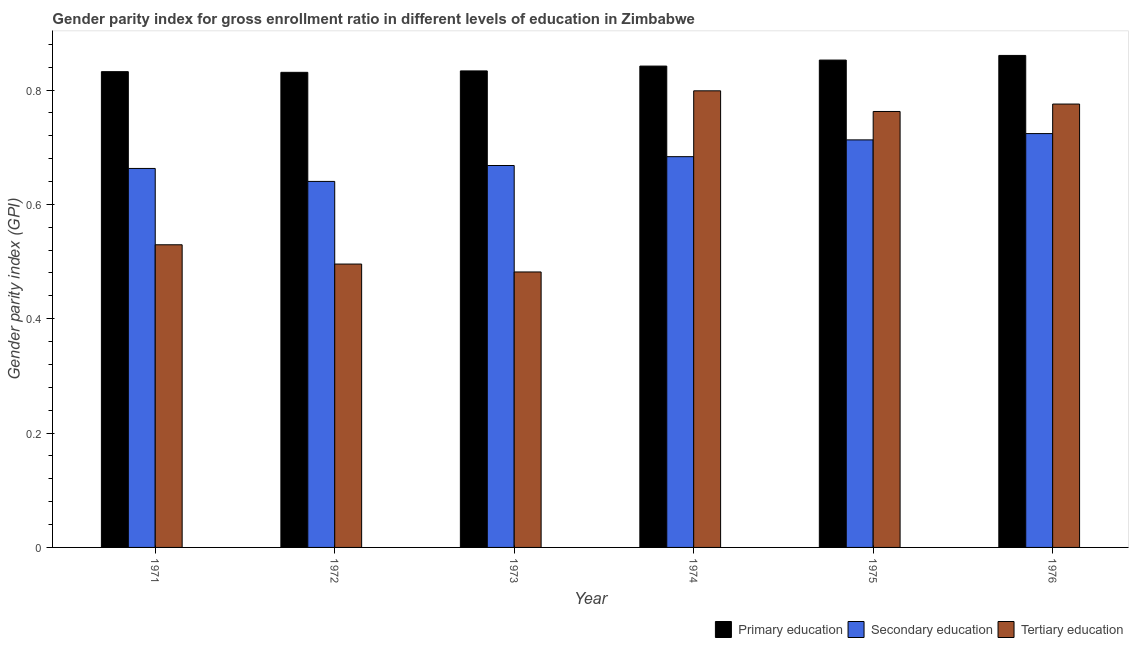How many different coloured bars are there?
Make the answer very short. 3. How many groups of bars are there?
Offer a terse response. 6. How many bars are there on the 6th tick from the right?
Ensure brevity in your answer.  3. What is the label of the 1st group of bars from the left?
Offer a very short reply. 1971. In how many cases, is the number of bars for a given year not equal to the number of legend labels?
Give a very brief answer. 0. What is the gender parity index in primary education in 1972?
Give a very brief answer. 0.83. Across all years, what is the maximum gender parity index in tertiary education?
Make the answer very short. 0.8. Across all years, what is the minimum gender parity index in primary education?
Offer a terse response. 0.83. In which year was the gender parity index in tertiary education maximum?
Offer a very short reply. 1974. In which year was the gender parity index in secondary education minimum?
Offer a terse response. 1972. What is the total gender parity index in tertiary education in the graph?
Ensure brevity in your answer.  3.84. What is the difference between the gender parity index in primary education in 1972 and that in 1974?
Your answer should be compact. -0.01. What is the difference between the gender parity index in secondary education in 1973 and the gender parity index in tertiary education in 1976?
Give a very brief answer. -0.06. What is the average gender parity index in primary education per year?
Keep it short and to the point. 0.84. In the year 1975, what is the difference between the gender parity index in secondary education and gender parity index in primary education?
Your answer should be compact. 0. What is the ratio of the gender parity index in tertiary education in 1972 to that in 1976?
Your response must be concise. 0.64. What is the difference between the highest and the second highest gender parity index in tertiary education?
Your response must be concise. 0.02. What is the difference between the highest and the lowest gender parity index in secondary education?
Make the answer very short. 0.08. Is the sum of the gender parity index in secondary education in 1971 and 1975 greater than the maximum gender parity index in tertiary education across all years?
Your response must be concise. Yes. What does the 2nd bar from the left in 1971 represents?
Ensure brevity in your answer.  Secondary education. How many bars are there?
Your answer should be very brief. 18. Are all the bars in the graph horizontal?
Keep it short and to the point. No. Are the values on the major ticks of Y-axis written in scientific E-notation?
Your answer should be compact. No. How many legend labels are there?
Offer a very short reply. 3. How are the legend labels stacked?
Your response must be concise. Horizontal. What is the title of the graph?
Your answer should be compact. Gender parity index for gross enrollment ratio in different levels of education in Zimbabwe. What is the label or title of the Y-axis?
Your response must be concise. Gender parity index (GPI). What is the Gender parity index (GPI) of Primary education in 1971?
Provide a succinct answer. 0.83. What is the Gender parity index (GPI) in Secondary education in 1971?
Give a very brief answer. 0.66. What is the Gender parity index (GPI) in Tertiary education in 1971?
Keep it short and to the point. 0.53. What is the Gender parity index (GPI) of Primary education in 1972?
Give a very brief answer. 0.83. What is the Gender parity index (GPI) of Secondary education in 1972?
Ensure brevity in your answer.  0.64. What is the Gender parity index (GPI) of Tertiary education in 1972?
Keep it short and to the point. 0.5. What is the Gender parity index (GPI) of Primary education in 1973?
Your answer should be compact. 0.83. What is the Gender parity index (GPI) of Secondary education in 1973?
Your answer should be compact. 0.67. What is the Gender parity index (GPI) in Tertiary education in 1973?
Your answer should be very brief. 0.48. What is the Gender parity index (GPI) of Primary education in 1974?
Ensure brevity in your answer.  0.84. What is the Gender parity index (GPI) in Secondary education in 1974?
Your response must be concise. 0.68. What is the Gender parity index (GPI) of Tertiary education in 1974?
Provide a succinct answer. 0.8. What is the Gender parity index (GPI) in Primary education in 1975?
Make the answer very short. 0.85. What is the Gender parity index (GPI) in Secondary education in 1975?
Provide a short and direct response. 0.71. What is the Gender parity index (GPI) of Tertiary education in 1975?
Your answer should be very brief. 0.76. What is the Gender parity index (GPI) in Primary education in 1976?
Give a very brief answer. 0.86. What is the Gender parity index (GPI) of Secondary education in 1976?
Keep it short and to the point. 0.72. What is the Gender parity index (GPI) in Tertiary education in 1976?
Provide a succinct answer. 0.78. Across all years, what is the maximum Gender parity index (GPI) in Primary education?
Make the answer very short. 0.86. Across all years, what is the maximum Gender parity index (GPI) of Secondary education?
Make the answer very short. 0.72. Across all years, what is the maximum Gender parity index (GPI) of Tertiary education?
Keep it short and to the point. 0.8. Across all years, what is the minimum Gender parity index (GPI) of Primary education?
Give a very brief answer. 0.83. Across all years, what is the minimum Gender parity index (GPI) of Secondary education?
Offer a very short reply. 0.64. Across all years, what is the minimum Gender parity index (GPI) in Tertiary education?
Provide a short and direct response. 0.48. What is the total Gender parity index (GPI) of Primary education in the graph?
Ensure brevity in your answer.  5.05. What is the total Gender parity index (GPI) of Secondary education in the graph?
Give a very brief answer. 4.09. What is the total Gender parity index (GPI) of Tertiary education in the graph?
Provide a short and direct response. 3.84. What is the difference between the Gender parity index (GPI) of Primary education in 1971 and that in 1972?
Your answer should be compact. 0. What is the difference between the Gender parity index (GPI) of Secondary education in 1971 and that in 1972?
Keep it short and to the point. 0.02. What is the difference between the Gender parity index (GPI) of Tertiary education in 1971 and that in 1972?
Offer a terse response. 0.03. What is the difference between the Gender parity index (GPI) of Primary education in 1971 and that in 1973?
Your answer should be very brief. -0. What is the difference between the Gender parity index (GPI) in Secondary education in 1971 and that in 1973?
Keep it short and to the point. -0.01. What is the difference between the Gender parity index (GPI) in Tertiary education in 1971 and that in 1973?
Give a very brief answer. 0.05. What is the difference between the Gender parity index (GPI) of Primary education in 1971 and that in 1974?
Provide a short and direct response. -0.01. What is the difference between the Gender parity index (GPI) in Secondary education in 1971 and that in 1974?
Keep it short and to the point. -0.02. What is the difference between the Gender parity index (GPI) of Tertiary education in 1971 and that in 1974?
Your response must be concise. -0.27. What is the difference between the Gender parity index (GPI) in Primary education in 1971 and that in 1975?
Provide a short and direct response. -0.02. What is the difference between the Gender parity index (GPI) in Secondary education in 1971 and that in 1975?
Ensure brevity in your answer.  -0.05. What is the difference between the Gender parity index (GPI) of Tertiary education in 1971 and that in 1975?
Make the answer very short. -0.23. What is the difference between the Gender parity index (GPI) of Primary education in 1971 and that in 1976?
Provide a succinct answer. -0.03. What is the difference between the Gender parity index (GPI) of Secondary education in 1971 and that in 1976?
Your answer should be compact. -0.06. What is the difference between the Gender parity index (GPI) of Tertiary education in 1971 and that in 1976?
Provide a succinct answer. -0.25. What is the difference between the Gender parity index (GPI) of Primary education in 1972 and that in 1973?
Make the answer very short. -0. What is the difference between the Gender parity index (GPI) of Secondary education in 1972 and that in 1973?
Ensure brevity in your answer.  -0.03. What is the difference between the Gender parity index (GPI) in Tertiary education in 1972 and that in 1973?
Give a very brief answer. 0.01. What is the difference between the Gender parity index (GPI) of Primary education in 1972 and that in 1974?
Offer a terse response. -0.01. What is the difference between the Gender parity index (GPI) of Secondary education in 1972 and that in 1974?
Make the answer very short. -0.04. What is the difference between the Gender parity index (GPI) of Tertiary education in 1972 and that in 1974?
Ensure brevity in your answer.  -0.3. What is the difference between the Gender parity index (GPI) of Primary education in 1972 and that in 1975?
Provide a short and direct response. -0.02. What is the difference between the Gender parity index (GPI) of Secondary education in 1972 and that in 1975?
Your response must be concise. -0.07. What is the difference between the Gender parity index (GPI) of Tertiary education in 1972 and that in 1975?
Offer a very short reply. -0.27. What is the difference between the Gender parity index (GPI) in Primary education in 1972 and that in 1976?
Keep it short and to the point. -0.03. What is the difference between the Gender parity index (GPI) of Secondary education in 1972 and that in 1976?
Give a very brief answer. -0.08. What is the difference between the Gender parity index (GPI) of Tertiary education in 1972 and that in 1976?
Your response must be concise. -0.28. What is the difference between the Gender parity index (GPI) of Primary education in 1973 and that in 1974?
Provide a short and direct response. -0.01. What is the difference between the Gender parity index (GPI) in Secondary education in 1973 and that in 1974?
Offer a very short reply. -0.02. What is the difference between the Gender parity index (GPI) of Tertiary education in 1973 and that in 1974?
Offer a terse response. -0.32. What is the difference between the Gender parity index (GPI) in Primary education in 1973 and that in 1975?
Provide a succinct answer. -0.02. What is the difference between the Gender parity index (GPI) in Secondary education in 1973 and that in 1975?
Offer a very short reply. -0.04. What is the difference between the Gender parity index (GPI) of Tertiary education in 1973 and that in 1975?
Your answer should be very brief. -0.28. What is the difference between the Gender parity index (GPI) in Primary education in 1973 and that in 1976?
Offer a very short reply. -0.03. What is the difference between the Gender parity index (GPI) in Secondary education in 1973 and that in 1976?
Provide a short and direct response. -0.06. What is the difference between the Gender parity index (GPI) in Tertiary education in 1973 and that in 1976?
Your answer should be very brief. -0.29. What is the difference between the Gender parity index (GPI) in Primary education in 1974 and that in 1975?
Provide a succinct answer. -0.01. What is the difference between the Gender parity index (GPI) of Secondary education in 1974 and that in 1975?
Your response must be concise. -0.03. What is the difference between the Gender parity index (GPI) in Tertiary education in 1974 and that in 1975?
Provide a short and direct response. 0.04. What is the difference between the Gender parity index (GPI) in Primary education in 1974 and that in 1976?
Ensure brevity in your answer.  -0.02. What is the difference between the Gender parity index (GPI) in Secondary education in 1974 and that in 1976?
Your answer should be very brief. -0.04. What is the difference between the Gender parity index (GPI) of Tertiary education in 1974 and that in 1976?
Provide a short and direct response. 0.02. What is the difference between the Gender parity index (GPI) in Primary education in 1975 and that in 1976?
Make the answer very short. -0.01. What is the difference between the Gender parity index (GPI) in Secondary education in 1975 and that in 1976?
Offer a terse response. -0.01. What is the difference between the Gender parity index (GPI) in Tertiary education in 1975 and that in 1976?
Ensure brevity in your answer.  -0.01. What is the difference between the Gender parity index (GPI) of Primary education in 1971 and the Gender parity index (GPI) of Secondary education in 1972?
Keep it short and to the point. 0.19. What is the difference between the Gender parity index (GPI) of Primary education in 1971 and the Gender parity index (GPI) of Tertiary education in 1972?
Offer a terse response. 0.34. What is the difference between the Gender parity index (GPI) of Secondary education in 1971 and the Gender parity index (GPI) of Tertiary education in 1972?
Provide a succinct answer. 0.17. What is the difference between the Gender parity index (GPI) of Primary education in 1971 and the Gender parity index (GPI) of Secondary education in 1973?
Provide a succinct answer. 0.16. What is the difference between the Gender parity index (GPI) in Primary education in 1971 and the Gender parity index (GPI) in Tertiary education in 1973?
Provide a short and direct response. 0.35. What is the difference between the Gender parity index (GPI) of Secondary education in 1971 and the Gender parity index (GPI) of Tertiary education in 1973?
Your answer should be very brief. 0.18. What is the difference between the Gender parity index (GPI) of Primary education in 1971 and the Gender parity index (GPI) of Secondary education in 1974?
Offer a very short reply. 0.15. What is the difference between the Gender parity index (GPI) of Primary education in 1971 and the Gender parity index (GPI) of Tertiary education in 1974?
Your response must be concise. 0.03. What is the difference between the Gender parity index (GPI) in Secondary education in 1971 and the Gender parity index (GPI) in Tertiary education in 1974?
Provide a succinct answer. -0.14. What is the difference between the Gender parity index (GPI) of Primary education in 1971 and the Gender parity index (GPI) of Secondary education in 1975?
Your answer should be very brief. 0.12. What is the difference between the Gender parity index (GPI) of Primary education in 1971 and the Gender parity index (GPI) of Tertiary education in 1975?
Keep it short and to the point. 0.07. What is the difference between the Gender parity index (GPI) in Secondary education in 1971 and the Gender parity index (GPI) in Tertiary education in 1975?
Your answer should be very brief. -0.1. What is the difference between the Gender parity index (GPI) of Primary education in 1971 and the Gender parity index (GPI) of Secondary education in 1976?
Your response must be concise. 0.11. What is the difference between the Gender parity index (GPI) in Primary education in 1971 and the Gender parity index (GPI) in Tertiary education in 1976?
Your answer should be very brief. 0.06. What is the difference between the Gender parity index (GPI) of Secondary education in 1971 and the Gender parity index (GPI) of Tertiary education in 1976?
Give a very brief answer. -0.11. What is the difference between the Gender parity index (GPI) of Primary education in 1972 and the Gender parity index (GPI) of Secondary education in 1973?
Make the answer very short. 0.16. What is the difference between the Gender parity index (GPI) of Primary education in 1972 and the Gender parity index (GPI) of Tertiary education in 1973?
Keep it short and to the point. 0.35. What is the difference between the Gender parity index (GPI) of Secondary education in 1972 and the Gender parity index (GPI) of Tertiary education in 1973?
Ensure brevity in your answer.  0.16. What is the difference between the Gender parity index (GPI) of Primary education in 1972 and the Gender parity index (GPI) of Secondary education in 1974?
Your response must be concise. 0.15. What is the difference between the Gender parity index (GPI) in Primary education in 1972 and the Gender parity index (GPI) in Tertiary education in 1974?
Offer a terse response. 0.03. What is the difference between the Gender parity index (GPI) in Secondary education in 1972 and the Gender parity index (GPI) in Tertiary education in 1974?
Make the answer very short. -0.16. What is the difference between the Gender parity index (GPI) in Primary education in 1972 and the Gender parity index (GPI) in Secondary education in 1975?
Your answer should be very brief. 0.12. What is the difference between the Gender parity index (GPI) of Primary education in 1972 and the Gender parity index (GPI) of Tertiary education in 1975?
Keep it short and to the point. 0.07. What is the difference between the Gender parity index (GPI) in Secondary education in 1972 and the Gender parity index (GPI) in Tertiary education in 1975?
Your answer should be compact. -0.12. What is the difference between the Gender parity index (GPI) of Primary education in 1972 and the Gender parity index (GPI) of Secondary education in 1976?
Your answer should be compact. 0.11. What is the difference between the Gender parity index (GPI) of Primary education in 1972 and the Gender parity index (GPI) of Tertiary education in 1976?
Offer a very short reply. 0.06. What is the difference between the Gender parity index (GPI) in Secondary education in 1972 and the Gender parity index (GPI) in Tertiary education in 1976?
Give a very brief answer. -0.14. What is the difference between the Gender parity index (GPI) in Primary education in 1973 and the Gender parity index (GPI) in Secondary education in 1974?
Your answer should be very brief. 0.15. What is the difference between the Gender parity index (GPI) of Primary education in 1973 and the Gender parity index (GPI) of Tertiary education in 1974?
Make the answer very short. 0.03. What is the difference between the Gender parity index (GPI) of Secondary education in 1973 and the Gender parity index (GPI) of Tertiary education in 1974?
Your answer should be compact. -0.13. What is the difference between the Gender parity index (GPI) in Primary education in 1973 and the Gender parity index (GPI) in Secondary education in 1975?
Provide a succinct answer. 0.12. What is the difference between the Gender parity index (GPI) in Primary education in 1973 and the Gender parity index (GPI) in Tertiary education in 1975?
Ensure brevity in your answer.  0.07. What is the difference between the Gender parity index (GPI) in Secondary education in 1973 and the Gender parity index (GPI) in Tertiary education in 1975?
Your answer should be very brief. -0.09. What is the difference between the Gender parity index (GPI) of Primary education in 1973 and the Gender parity index (GPI) of Secondary education in 1976?
Give a very brief answer. 0.11. What is the difference between the Gender parity index (GPI) in Primary education in 1973 and the Gender parity index (GPI) in Tertiary education in 1976?
Provide a succinct answer. 0.06. What is the difference between the Gender parity index (GPI) in Secondary education in 1973 and the Gender parity index (GPI) in Tertiary education in 1976?
Offer a terse response. -0.11. What is the difference between the Gender parity index (GPI) of Primary education in 1974 and the Gender parity index (GPI) of Secondary education in 1975?
Offer a terse response. 0.13. What is the difference between the Gender parity index (GPI) of Primary education in 1974 and the Gender parity index (GPI) of Tertiary education in 1975?
Your response must be concise. 0.08. What is the difference between the Gender parity index (GPI) of Secondary education in 1974 and the Gender parity index (GPI) of Tertiary education in 1975?
Make the answer very short. -0.08. What is the difference between the Gender parity index (GPI) in Primary education in 1974 and the Gender parity index (GPI) in Secondary education in 1976?
Give a very brief answer. 0.12. What is the difference between the Gender parity index (GPI) in Primary education in 1974 and the Gender parity index (GPI) in Tertiary education in 1976?
Provide a succinct answer. 0.07. What is the difference between the Gender parity index (GPI) of Secondary education in 1974 and the Gender parity index (GPI) of Tertiary education in 1976?
Keep it short and to the point. -0.09. What is the difference between the Gender parity index (GPI) of Primary education in 1975 and the Gender parity index (GPI) of Secondary education in 1976?
Your answer should be compact. 0.13. What is the difference between the Gender parity index (GPI) of Primary education in 1975 and the Gender parity index (GPI) of Tertiary education in 1976?
Offer a terse response. 0.08. What is the difference between the Gender parity index (GPI) of Secondary education in 1975 and the Gender parity index (GPI) of Tertiary education in 1976?
Offer a terse response. -0.06. What is the average Gender parity index (GPI) in Primary education per year?
Make the answer very short. 0.84. What is the average Gender parity index (GPI) of Secondary education per year?
Your response must be concise. 0.68. What is the average Gender parity index (GPI) of Tertiary education per year?
Make the answer very short. 0.64. In the year 1971, what is the difference between the Gender parity index (GPI) of Primary education and Gender parity index (GPI) of Secondary education?
Provide a short and direct response. 0.17. In the year 1971, what is the difference between the Gender parity index (GPI) of Primary education and Gender parity index (GPI) of Tertiary education?
Your answer should be compact. 0.3. In the year 1971, what is the difference between the Gender parity index (GPI) of Secondary education and Gender parity index (GPI) of Tertiary education?
Provide a short and direct response. 0.13. In the year 1972, what is the difference between the Gender parity index (GPI) in Primary education and Gender parity index (GPI) in Secondary education?
Ensure brevity in your answer.  0.19. In the year 1972, what is the difference between the Gender parity index (GPI) in Primary education and Gender parity index (GPI) in Tertiary education?
Your answer should be very brief. 0.34. In the year 1972, what is the difference between the Gender parity index (GPI) of Secondary education and Gender parity index (GPI) of Tertiary education?
Offer a very short reply. 0.14. In the year 1973, what is the difference between the Gender parity index (GPI) in Primary education and Gender parity index (GPI) in Secondary education?
Your response must be concise. 0.17. In the year 1973, what is the difference between the Gender parity index (GPI) of Primary education and Gender parity index (GPI) of Tertiary education?
Your answer should be very brief. 0.35. In the year 1973, what is the difference between the Gender parity index (GPI) of Secondary education and Gender parity index (GPI) of Tertiary education?
Offer a terse response. 0.19. In the year 1974, what is the difference between the Gender parity index (GPI) of Primary education and Gender parity index (GPI) of Secondary education?
Ensure brevity in your answer.  0.16. In the year 1974, what is the difference between the Gender parity index (GPI) of Primary education and Gender parity index (GPI) of Tertiary education?
Make the answer very short. 0.04. In the year 1974, what is the difference between the Gender parity index (GPI) of Secondary education and Gender parity index (GPI) of Tertiary education?
Offer a terse response. -0.12. In the year 1975, what is the difference between the Gender parity index (GPI) of Primary education and Gender parity index (GPI) of Secondary education?
Your answer should be compact. 0.14. In the year 1975, what is the difference between the Gender parity index (GPI) of Primary education and Gender parity index (GPI) of Tertiary education?
Provide a short and direct response. 0.09. In the year 1975, what is the difference between the Gender parity index (GPI) of Secondary education and Gender parity index (GPI) of Tertiary education?
Offer a very short reply. -0.05. In the year 1976, what is the difference between the Gender parity index (GPI) in Primary education and Gender parity index (GPI) in Secondary education?
Offer a very short reply. 0.14. In the year 1976, what is the difference between the Gender parity index (GPI) of Primary education and Gender parity index (GPI) of Tertiary education?
Ensure brevity in your answer.  0.09. In the year 1976, what is the difference between the Gender parity index (GPI) of Secondary education and Gender parity index (GPI) of Tertiary education?
Provide a succinct answer. -0.05. What is the ratio of the Gender parity index (GPI) of Primary education in 1971 to that in 1972?
Give a very brief answer. 1. What is the ratio of the Gender parity index (GPI) of Secondary education in 1971 to that in 1972?
Your response must be concise. 1.04. What is the ratio of the Gender parity index (GPI) in Tertiary education in 1971 to that in 1972?
Ensure brevity in your answer.  1.07. What is the ratio of the Gender parity index (GPI) in Primary education in 1971 to that in 1973?
Ensure brevity in your answer.  1. What is the ratio of the Gender parity index (GPI) in Secondary education in 1971 to that in 1973?
Offer a terse response. 0.99. What is the ratio of the Gender parity index (GPI) in Tertiary education in 1971 to that in 1973?
Provide a short and direct response. 1.1. What is the ratio of the Gender parity index (GPI) in Primary education in 1971 to that in 1974?
Your answer should be very brief. 0.99. What is the ratio of the Gender parity index (GPI) in Secondary education in 1971 to that in 1974?
Your answer should be very brief. 0.97. What is the ratio of the Gender parity index (GPI) of Tertiary education in 1971 to that in 1974?
Your answer should be compact. 0.66. What is the ratio of the Gender parity index (GPI) in Primary education in 1971 to that in 1975?
Provide a succinct answer. 0.98. What is the ratio of the Gender parity index (GPI) of Secondary education in 1971 to that in 1975?
Your answer should be compact. 0.93. What is the ratio of the Gender parity index (GPI) in Tertiary education in 1971 to that in 1975?
Offer a terse response. 0.69. What is the ratio of the Gender parity index (GPI) of Secondary education in 1971 to that in 1976?
Your answer should be very brief. 0.92. What is the ratio of the Gender parity index (GPI) in Tertiary education in 1971 to that in 1976?
Provide a succinct answer. 0.68. What is the ratio of the Gender parity index (GPI) in Secondary education in 1972 to that in 1973?
Offer a terse response. 0.96. What is the ratio of the Gender parity index (GPI) of Tertiary education in 1972 to that in 1973?
Make the answer very short. 1.03. What is the ratio of the Gender parity index (GPI) in Primary education in 1972 to that in 1974?
Ensure brevity in your answer.  0.99. What is the ratio of the Gender parity index (GPI) in Secondary education in 1972 to that in 1974?
Ensure brevity in your answer.  0.94. What is the ratio of the Gender parity index (GPI) of Tertiary education in 1972 to that in 1974?
Provide a succinct answer. 0.62. What is the ratio of the Gender parity index (GPI) of Primary education in 1972 to that in 1975?
Offer a very short reply. 0.97. What is the ratio of the Gender parity index (GPI) of Secondary education in 1972 to that in 1975?
Your answer should be compact. 0.9. What is the ratio of the Gender parity index (GPI) of Tertiary education in 1972 to that in 1975?
Provide a short and direct response. 0.65. What is the ratio of the Gender parity index (GPI) in Primary education in 1972 to that in 1976?
Your answer should be very brief. 0.97. What is the ratio of the Gender parity index (GPI) in Secondary education in 1972 to that in 1976?
Provide a short and direct response. 0.88. What is the ratio of the Gender parity index (GPI) of Tertiary education in 1972 to that in 1976?
Your answer should be very brief. 0.64. What is the ratio of the Gender parity index (GPI) in Primary education in 1973 to that in 1974?
Provide a short and direct response. 0.99. What is the ratio of the Gender parity index (GPI) in Secondary education in 1973 to that in 1974?
Provide a short and direct response. 0.98. What is the ratio of the Gender parity index (GPI) of Tertiary education in 1973 to that in 1974?
Offer a terse response. 0.6. What is the ratio of the Gender parity index (GPI) in Primary education in 1973 to that in 1975?
Your response must be concise. 0.98. What is the ratio of the Gender parity index (GPI) in Secondary education in 1973 to that in 1975?
Your answer should be compact. 0.94. What is the ratio of the Gender parity index (GPI) of Tertiary education in 1973 to that in 1975?
Your response must be concise. 0.63. What is the ratio of the Gender parity index (GPI) in Primary education in 1973 to that in 1976?
Keep it short and to the point. 0.97. What is the ratio of the Gender parity index (GPI) of Secondary education in 1973 to that in 1976?
Offer a very short reply. 0.92. What is the ratio of the Gender parity index (GPI) in Tertiary education in 1973 to that in 1976?
Provide a short and direct response. 0.62. What is the ratio of the Gender parity index (GPI) of Secondary education in 1974 to that in 1975?
Your answer should be compact. 0.96. What is the ratio of the Gender parity index (GPI) of Tertiary education in 1974 to that in 1975?
Your answer should be very brief. 1.05. What is the ratio of the Gender parity index (GPI) in Primary education in 1974 to that in 1976?
Provide a short and direct response. 0.98. What is the ratio of the Gender parity index (GPI) of Secondary education in 1974 to that in 1976?
Offer a very short reply. 0.94. What is the ratio of the Gender parity index (GPI) of Tertiary education in 1974 to that in 1976?
Keep it short and to the point. 1.03. What is the ratio of the Gender parity index (GPI) in Primary education in 1975 to that in 1976?
Your response must be concise. 0.99. What is the ratio of the Gender parity index (GPI) of Tertiary education in 1975 to that in 1976?
Your answer should be compact. 0.98. What is the difference between the highest and the second highest Gender parity index (GPI) in Primary education?
Ensure brevity in your answer.  0.01. What is the difference between the highest and the second highest Gender parity index (GPI) of Secondary education?
Provide a short and direct response. 0.01. What is the difference between the highest and the second highest Gender parity index (GPI) in Tertiary education?
Keep it short and to the point. 0.02. What is the difference between the highest and the lowest Gender parity index (GPI) in Primary education?
Provide a succinct answer. 0.03. What is the difference between the highest and the lowest Gender parity index (GPI) of Secondary education?
Your answer should be compact. 0.08. What is the difference between the highest and the lowest Gender parity index (GPI) of Tertiary education?
Your answer should be very brief. 0.32. 